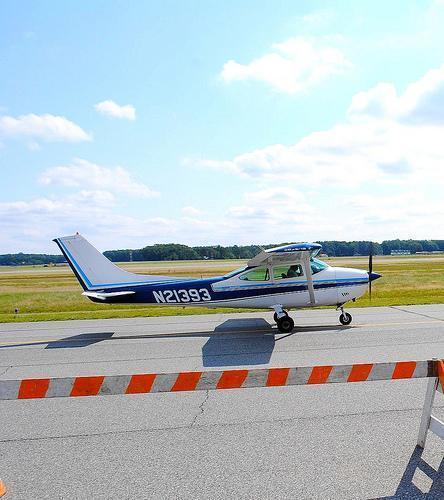How many planes are there?
Give a very brief answer. 1. How many stripes on the piece of painted wood are white?
Give a very brief answer. 10. 